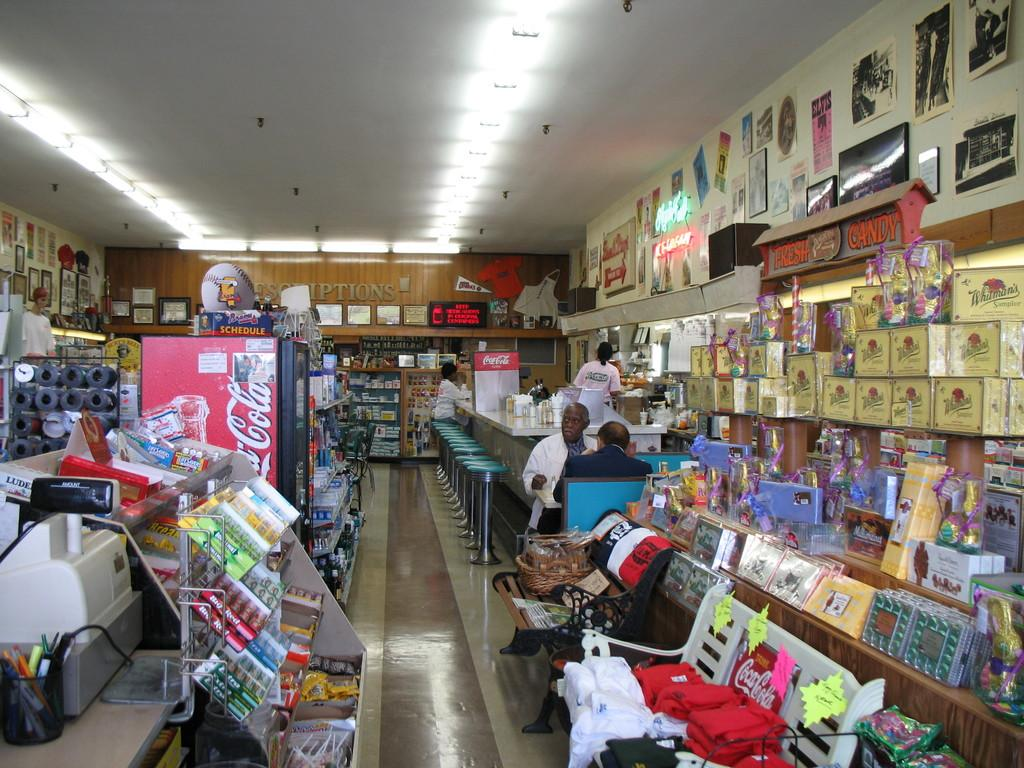<image>
Relay a brief, clear account of the picture shown. A sign advertising fresh candy hangs above a large display of Whitman's sampler boxes of chocolate. 